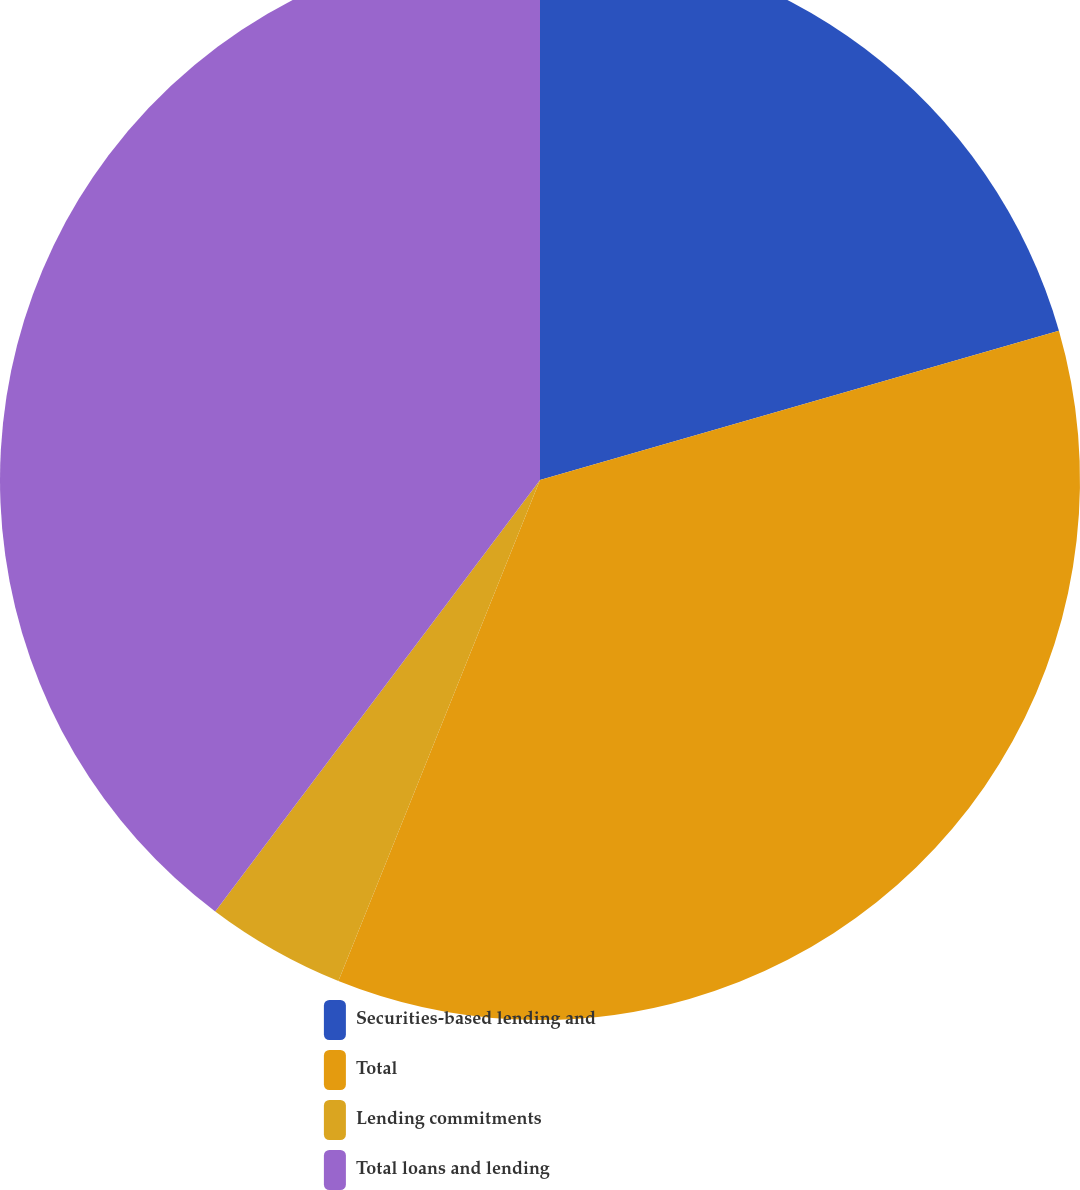Convert chart. <chart><loc_0><loc_0><loc_500><loc_500><pie_chart><fcel>Securities-based lending and<fcel>Total<fcel>Lending commitments<fcel>Total loans and lending<nl><fcel>20.54%<fcel>35.55%<fcel>4.18%<fcel>39.73%<nl></chart> 